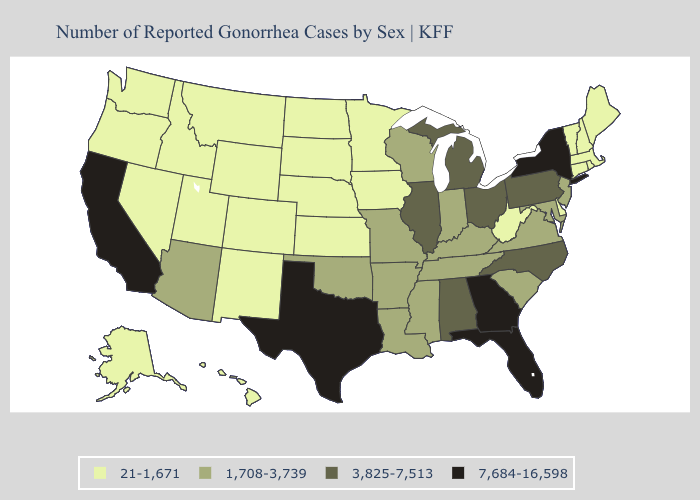What is the highest value in states that border Georgia?
Quick response, please. 7,684-16,598. What is the lowest value in states that border Missouri?
Give a very brief answer. 21-1,671. Which states have the lowest value in the USA?
Quick response, please. Alaska, Colorado, Connecticut, Delaware, Hawaii, Idaho, Iowa, Kansas, Maine, Massachusetts, Minnesota, Montana, Nebraska, Nevada, New Hampshire, New Mexico, North Dakota, Oregon, Rhode Island, South Dakota, Utah, Vermont, Washington, West Virginia, Wyoming. What is the value of South Dakota?
Answer briefly. 21-1,671. What is the lowest value in states that border Connecticut?
Concise answer only. 21-1,671. How many symbols are there in the legend?
Be succinct. 4. What is the highest value in the Northeast ?
Write a very short answer. 7,684-16,598. What is the value of Utah?
Short answer required. 21-1,671. Which states have the lowest value in the USA?
Keep it brief. Alaska, Colorado, Connecticut, Delaware, Hawaii, Idaho, Iowa, Kansas, Maine, Massachusetts, Minnesota, Montana, Nebraska, Nevada, New Hampshire, New Mexico, North Dakota, Oregon, Rhode Island, South Dakota, Utah, Vermont, Washington, West Virginia, Wyoming. Does Wisconsin have the lowest value in the USA?
Keep it brief. No. What is the value of Oregon?
Concise answer only. 21-1,671. Name the states that have a value in the range 1,708-3,739?
Write a very short answer. Arizona, Arkansas, Indiana, Kentucky, Louisiana, Maryland, Mississippi, Missouri, New Jersey, Oklahoma, South Carolina, Tennessee, Virginia, Wisconsin. Name the states that have a value in the range 7,684-16,598?
Quick response, please. California, Florida, Georgia, New York, Texas. What is the lowest value in the West?
Be succinct. 21-1,671. What is the value of Maine?
Be succinct. 21-1,671. 